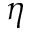Convert formula to latex. <formula><loc_0><loc_0><loc_500><loc_500>\eta</formula> 